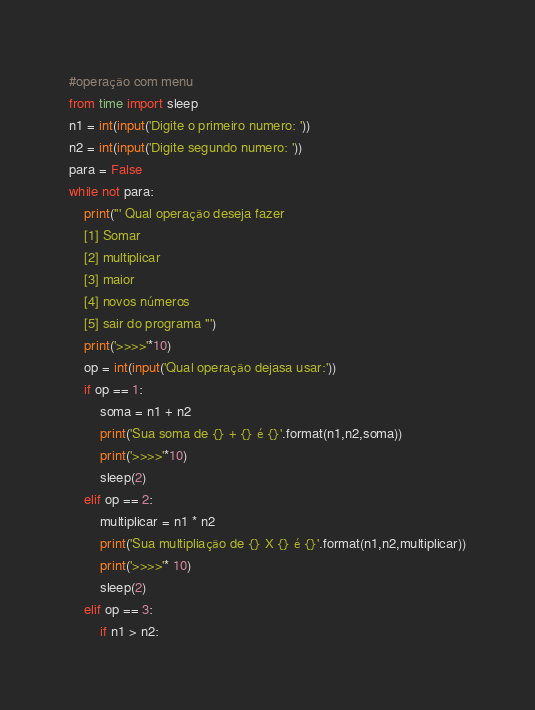Convert code to text. <code><loc_0><loc_0><loc_500><loc_500><_Python_>#operação com menu
from time import sleep
n1 = int(input('Digite o primeiro numero: '))
n2 = int(input('Digite segundo numero: '))
para = False
while not para:
    print(''' Qual operação deseja fazer
    [1] Somar
    [2] multiplicar
    [3] maior
    [4] novos números
    [5] sair do programa ''')
    print('>>>>'*10)
    op = int(input('Qual operação dejasa usar:'))
    if op == 1:
        soma = n1 + n2
        print('Sua soma de {} + {} é {}'.format(n1,n2,soma))
        print('>>>>'*10)
        sleep(2)
    elif op == 2:
        multiplicar = n1 * n2
        print('Sua multipliação de {} X {} é {}'.format(n1,n2,multiplicar))
        print('>>>>'* 10)
        sleep(2)
    elif op == 3:
        if n1 > n2:</code> 